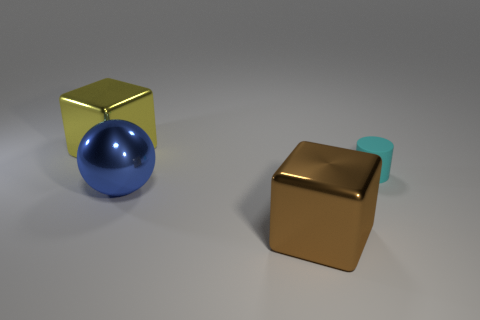Add 3 yellow metal objects. How many objects exist? 7 Subtract all spheres. How many objects are left? 3 Subtract all big blocks. Subtract all small matte objects. How many objects are left? 1 Add 3 cyan objects. How many cyan objects are left? 4 Add 4 big red shiny objects. How many big red shiny objects exist? 4 Subtract 1 brown cubes. How many objects are left? 3 